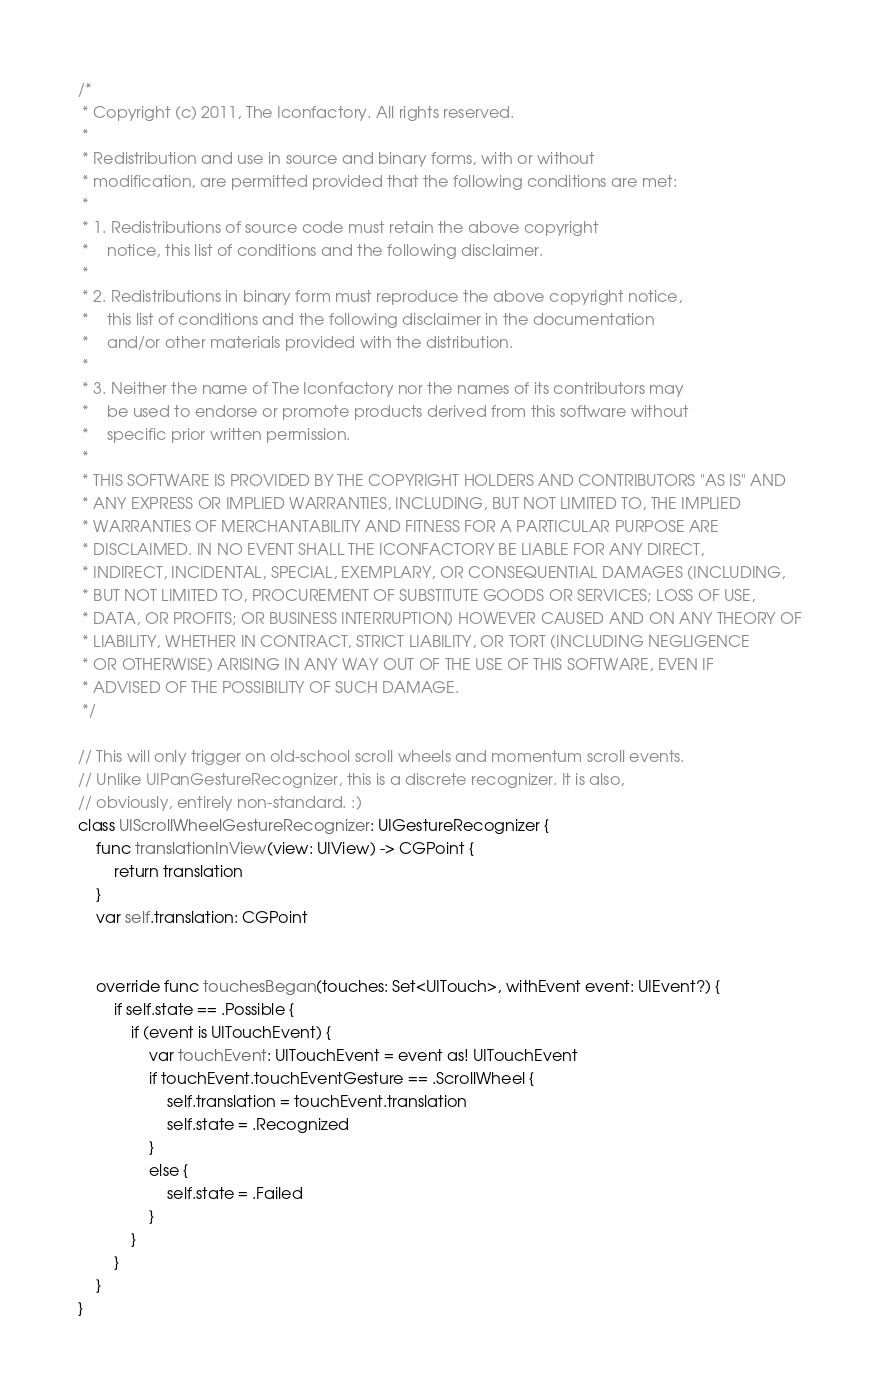Convert code to text. <code><loc_0><loc_0><loc_500><loc_500><_Swift_>/*
 * Copyright (c) 2011, The Iconfactory. All rights reserved.
 *
 * Redistribution and use in source and binary forms, with or without
 * modification, are permitted provided that the following conditions are met:
 *
 * 1. Redistributions of source code must retain the above copyright
 *    notice, this list of conditions and the following disclaimer.
 *
 * 2. Redistributions in binary form must reproduce the above copyright notice,
 *    this list of conditions and the following disclaimer in the documentation
 *    and/or other materials provided with the distribution.
 *
 * 3. Neither the name of The Iconfactory nor the names of its contributors may
 *    be used to endorse or promote products derived from this software without
 *    specific prior written permission.
 *
 * THIS SOFTWARE IS PROVIDED BY THE COPYRIGHT HOLDERS AND CONTRIBUTORS "AS IS" AND
 * ANY EXPRESS OR IMPLIED WARRANTIES, INCLUDING, BUT NOT LIMITED TO, THE IMPLIED
 * WARRANTIES OF MERCHANTABILITY AND FITNESS FOR A PARTICULAR PURPOSE ARE
 * DISCLAIMED. IN NO EVENT SHALL THE ICONFACTORY BE LIABLE FOR ANY DIRECT,
 * INDIRECT, INCIDENTAL, SPECIAL, EXEMPLARY, OR CONSEQUENTIAL DAMAGES (INCLUDING,
 * BUT NOT LIMITED TO, PROCUREMENT OF SUBSTITUTE GOODS OR SERVICES; LOSS OF USE,
 * DATA, OR PROFITS; OR BUSINESS INTERRUPTION) HOWEVER CAUSED AND ON ANY THEORY OF
 * LIABILITY, WHETHER IN CONTRACT, STRICT LIABILITY, OR TORT (INCLUDING NEGLIGENCE
 * OR OTHERWISE) ARISING IN ANY WAY OUT OF THE USE OF THIS SOFTWARE, EVEN IF
 * ADVISED OF THE POSSIBILITY OF SUCH DAMAGE.
 */

// This will only trigger on old-school scroll wheels and momentum scroll events.
// Unlike UIPanGestureRecognizer, this is a discrete recognizer. It is also,
// obviously, entirely non-standard. :)
class UIScrollWheelGestureRecognizer: UIGestureRecognizer {
    func translationInView(view: UIView) -> CGPoint {
        return translation
    }
    var self.translation: CGPoint


    override func touchesBegan(touches: Set<UITouch>, withEvent event: UIEvent?) {
        if self.state == .Possible {
            if (event is UITouchEvent) {
                var touchEvent: UITouchEvent = event as! UITouchEvent
                if touchEvent.touchEventGesture == .ScrollWheel {
                    self.translation = touchEvent.translation
                    self.state = .Recognized
                }
                else {
                    self.state = .Failed
                }
            }
        }
    }
}</code> 